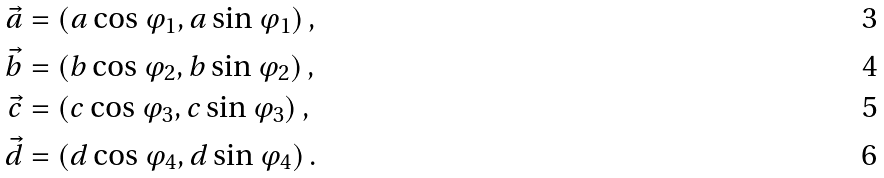Convert formula to latex. <formula><loc_0><loc_0><loc_500><loc_500>\vec { a } & = ( a \cos \varphi _ { 1 } , a \sin \varphi _ { 1 } ) \, , \\ \vec { b } & = ( b \cos \varphi _ { 2 } , b \sin \varphi _ { 2 } ) \, , \\ \vec { c } & = ( c \cos \varphi _ { 3 } , c \sin \varphi _ { 3 } ) \, , \\ \vec { d } & = ( d \cos \varphi _ { 4 } , d \sin \varphi _ { 4 } ) \, .</formula> 